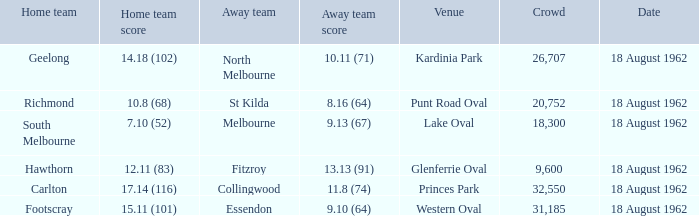What was the home team that scored 10.8 (68)? Richmond. 